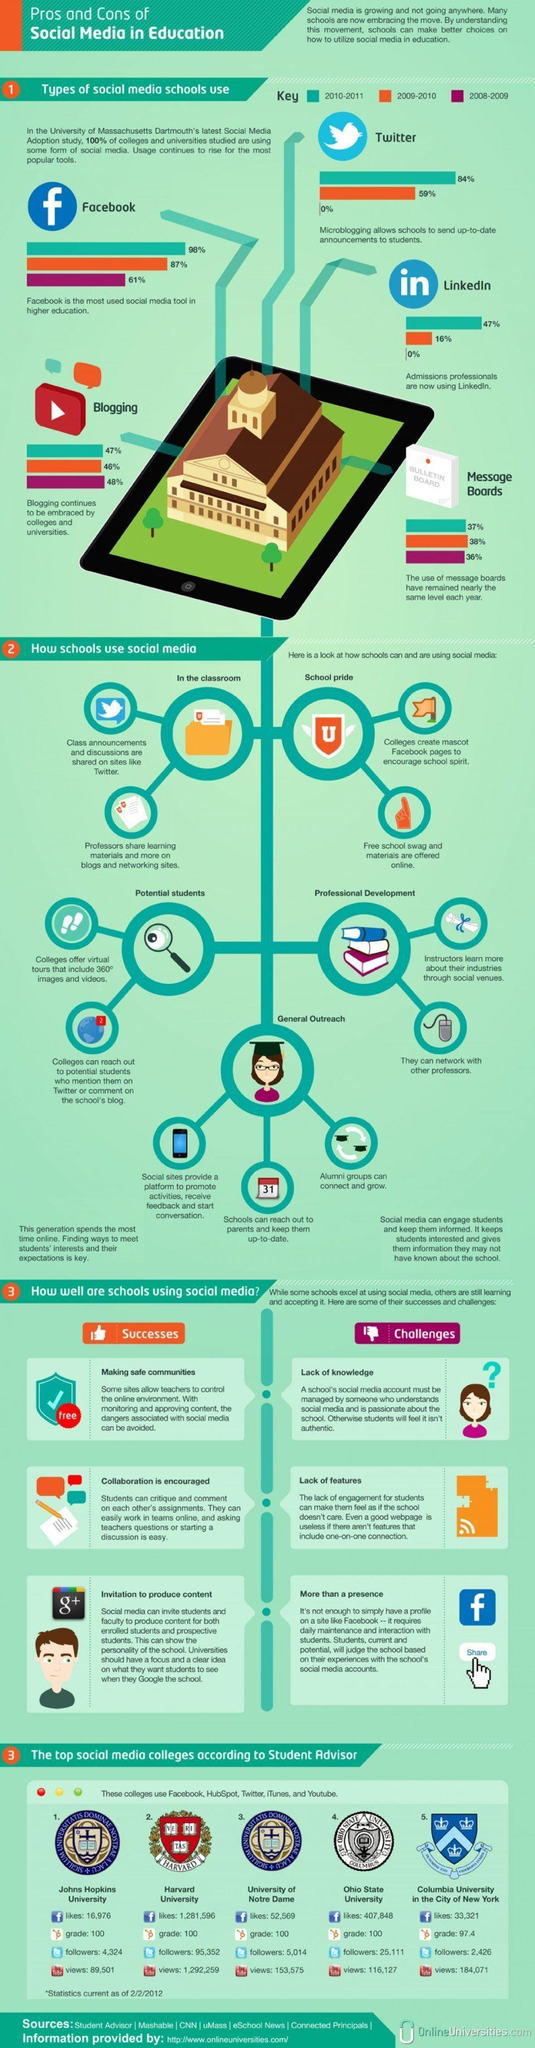Which social media tool was used the most by schools in the year 2010-2011?
Answer the question with a short phrase. Facebook Which social media tools were the least used in 2008-2009? Twitter, LinkedIn What is the average percentage of use of blogging by schools for the period 2008-2011? 47% What is the average percentage of use of message boards by schools for the period 2008-2011? 37% How many views does Ohio university have on YouTube, 89,501, 184,071, or 116,127? 116,127 What is the number of Facebook likes for Columbia University, 16,976, 33,321, or 52,569? 33,321 How many followers does Harvard university have on Twitter, 95,352, 5,014, or 25,111? 95,352 